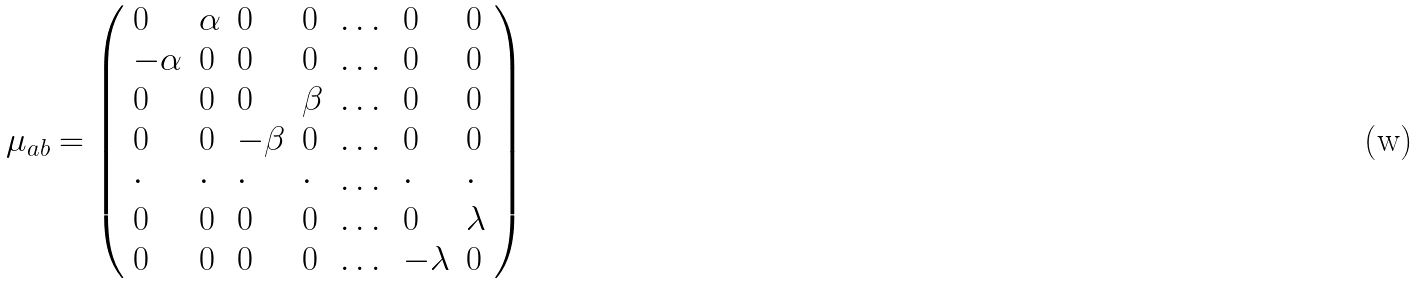Convert formula to latex. <formula><loc_0><loc_0><loc_500><loc_500>\mu _ { a b } = \left ( \begin{array} { l l l l l l l } 0 & \alpha & 0 & 0 & \dots & 0 & 0 \\ - \alpha & 0 & 0 & 0 & \dots & 0 & 0 \\ 0 & 0 & 0 & \beta & \dots & 0 & 0 \\ 0 & 0 & - \beta & 0 & \dots & 0 & 0 \\ \cdot & \cdot & \cdot & \cdot & \dots & \cdot & \cdot \\ 0 & 0 & 0 & 0 & \dots & 0 & \lambda \\ 0 & 0 & 0 & 0 & \dots & - \lambda & 0 \end{array} \right )</formula> 